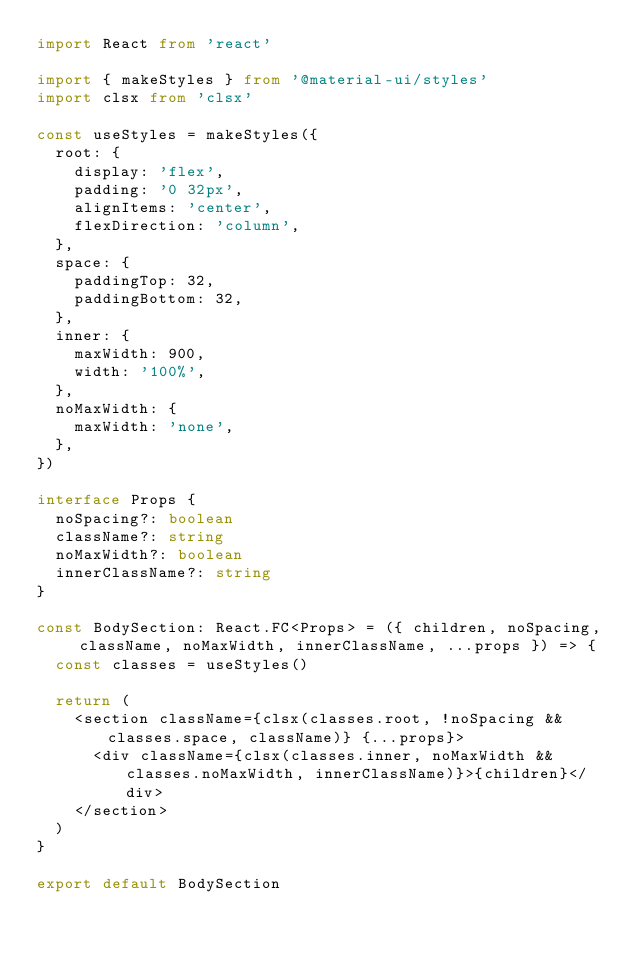<code> <loc_0><loc_0><loc_500><loc_500><_TypeScript_>import React from 'react'

import { makeStyles } from '@material-ui/styles'
import clsx from 'clsx'

const useStyles = makeStyles({
  root: {
    display: 'flex',
    padding: '0 32px',
    alignItems: 'center',
    flexDirection: 'column',
  },
  space: {
    paddingTop: 32,
    paddingBottom: 32,
  },
  inner: {
    maxWidth: 900,
    width: '100%',
  },
  noMaxWidth: {
    maxWidth: 'none',
  },
})

interface Props {
  noSpacing?: boolean
  className?: string
  noMaxWidth?: boolean
  innerClassName?: string
}

const BodySection: React.FC<Props> = ({ children, noSpacing, className, noMaxWidth, innerClassName, ...props }) => {
  const classes = useStyles()

  return (
    <section className={clsx(classes.root, !noSpacing && classes.space, className)} {...props}>
      <div className={clsx(classes.inner, noMaxWidth && classes.noMaxWidth, innerClassName)}>{children}</div>
    </section>
  )
}

export default BodySection
</code> 